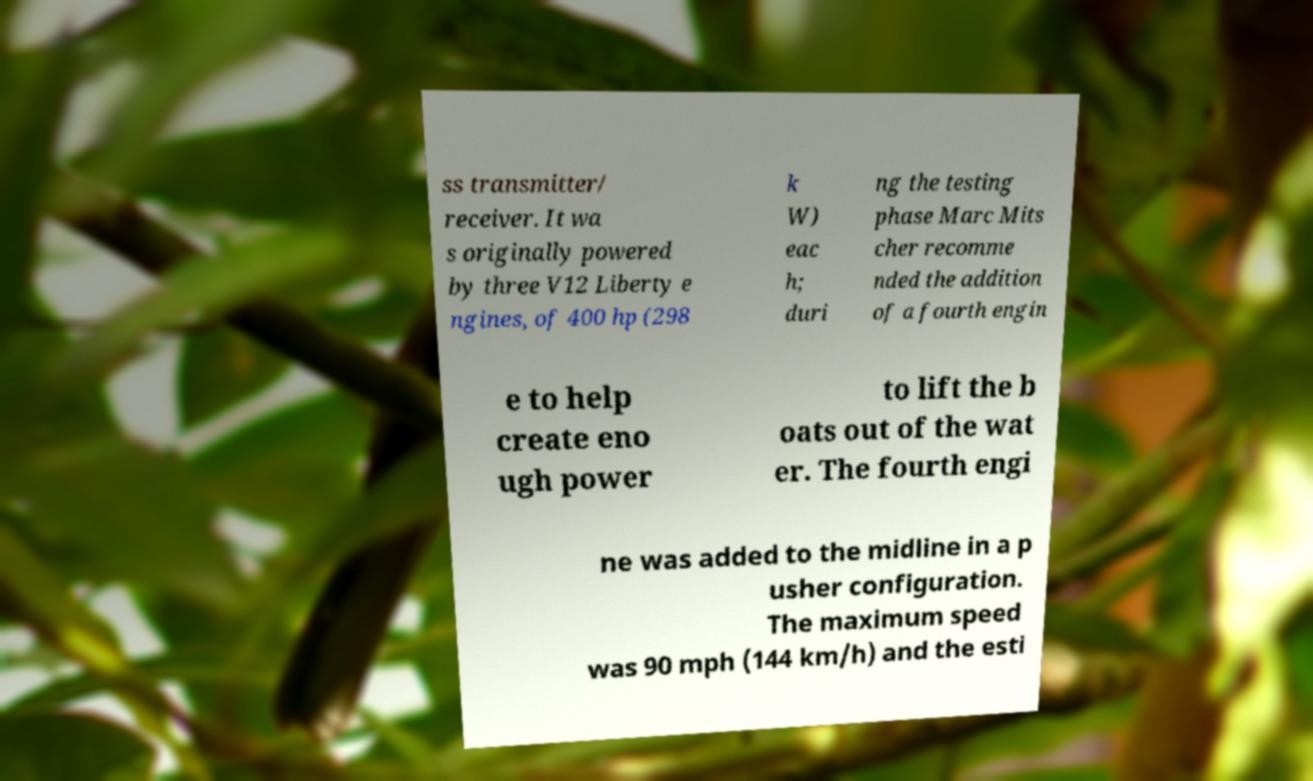Please identify and transcribe the text found in this image. ss transmitter/ receiver. It wa s originally powered by three V12 Liberty e ngines, of 400 hp (298 k W) eac h; duri ng the testing phase Marc Mits cher recomme nded the addition of a fourth engin e to help create eno ugh power to lift the b oats out of the wat er. The fourth engi ne was added to the midline in a p usher configuration. The maximum speed was 90 mph (144 km/h) and the esti 